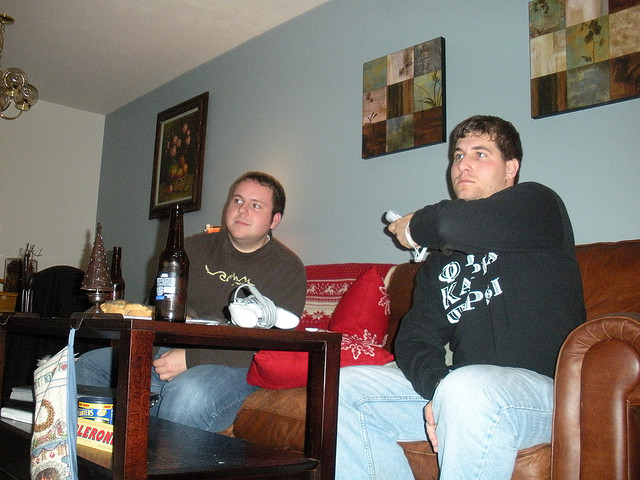Identify the text contained in this image. KA 